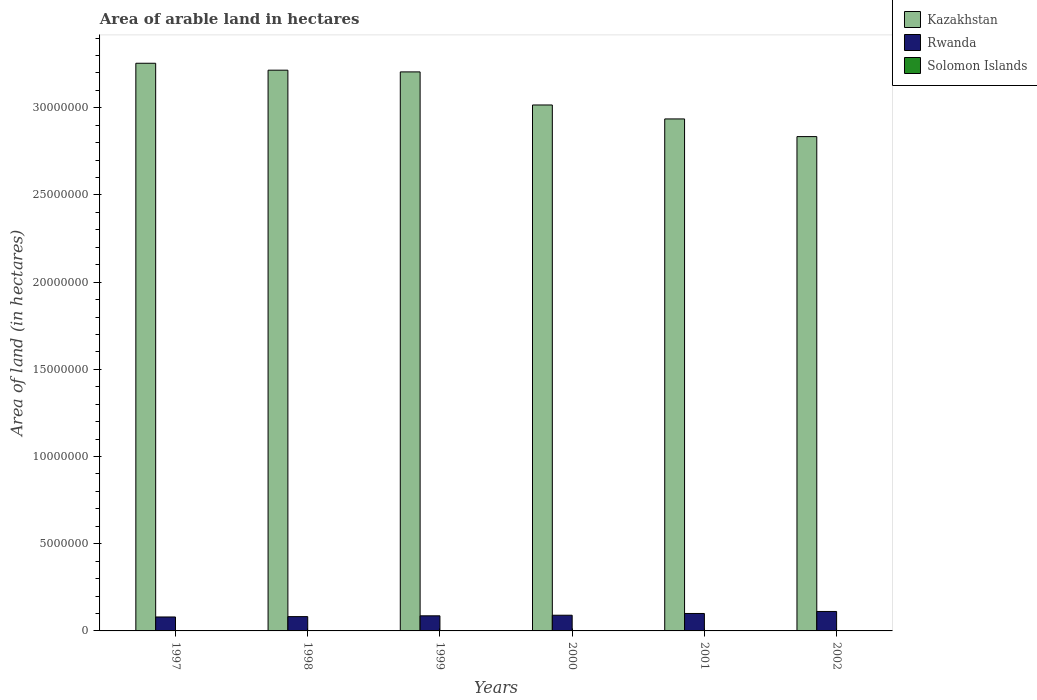How many different coloured bars are there?
Offer a very short reply. 3. How many groups of bars are there?
Keep it short and to the point. 6. Are the number of bars per tick equal to the number of legend labels?
Provide a short and direct response. Yes. Are the number of bars on each tick of the X-axis equal?
Your answer should be compact. Yes. How many bars are there on the 1st tick from the left?
Your answer should be very brief. 3. How many bars are there on the 1st tick from the right?
Your response must be concise. 3. What is the total arable land in Solomon Islands in 1999?
Your answer should be compact. 1.40e+04. Across all years, what is the maximum total arable land in Solomon Islands?
Your answer should be very brief. 1.50e+04. Across all years, what is the minimum total arable land in Solomon Islands?
Provide a succinct answer. 1.20e+04. What is the total total arable land in Solomon Islands in the graph?
Offer a very short reply. 8.30e+04. What is the difference between the total arable land in Rwanda in 1999 and that in 2002?
Offer a very short reply. -2.50e+05. What is the difference between the total arable land in Rwanda in 1998 and the total arable land in Solomon Islands in 1997?
Ensure brevity in your answer.  8.08e+05. What is the average total arable land in Kazakhstan per year?
Ensure brevity in your answer.  3.08e+07. In the year 2002, what is the difference between the total arable land in Rwanda and total arable land in Solomon Islands?
Offer a very short reply. 1.10e+06. What is the ratio of the total arable land in Rwanda in 1999 to that in 2002?
Your answer should be compact. 0.78. What is the difference between the highest and the second highest total arable land in Rwanda?
Keep it short and to the point. 1.16e+05. What is the difference between the highest and the lowest total arable land in Solomon Islands?
Make the answer very short. 3000. Is the sum of the total arable land in Solomon Islands in 1997 and 1998 greater than the maximum total arable land in Rwanda across all years?
Make the answer very short. No. What does the 2nd bar from the left in 2001 represents?
Offer a very short reply. Rwanda. What does the 2nd bar from the right in 2002 represents?
Your answer should be very brief. Rwanda. Is it the case that in every year, the sum of the total arable land in Kazakhstan and total arable land in Rwanda is greater than the total arable land in Solomon Islands?
Your answer should be very brief. Yes. How many bars are there?
Offer a terse response. 18. Are all the bars in the graph horizontal?
Your answer should be compact. No. Does the graph contain grids?
Make the answer very short. No. Where does the legend appear in the graph?
Your answer should be compact. Top right. How are the legend labels stacked?
Your response must be concise. Vertical. What is the title of the graph?
Provide a succinct answer. Area of arable land in hectares. What is the label or title of the Y-axis?
Keep it short and to the point. Area of land (in hectares). What is the Area of land (in hectares) in Kazakhstan in 1997?
Your answer should be very brief. 3.26e+07. What is the Area of land (in hectares) in Solomon Islands in 1997?
Make the answer very short. 1.20e+04. What is the Area of land (in hectares) of Kazakhstan in 1998?
Offer a very short reply. 3.22e+07. What is the Area of land (in hectares) of Rwanda in 1998?
Give a very brief answer. 8.20e+05. What is the Area of land (in hectares) in Solomon Islands in 1998?
Ensure brevity in your answer.  1.30e+04. What is the Area of land (in hectares) in Kazakhstan in 1999?
Ensure brevity in your answer.  3.21e+07. What is the Area of land (in hectares) in Rwanda in 1999?
Provide a short and direct response. 8.66e+05. What is the Area of land (in hectares) of Solomon Islands in 1999?
Keep it short and to the point. 1.40e+04. What is the Area of land (in hectares) of Kazakhstan in 2000?
Provide a succinct answer. 3.02e+07. What is the Area of land (in hectares) of Solomon Islands in 2000?
Make the answer very short. 1.40e+04. What is the Area of land (in hectares) of Kazakhstan in 2001?
Make the answer very short. 2.94e+07. What is the Area of land (in hectares) in Rwanda in 2001?
Ensure brevity in your answer.  1.00e+06. What is the Area of land (in hectares) in Solomon Islands in 2001?
Offer a terse response. 1.50e+04. What is the Area of land (in hectares) of Kazakhstan in 2002?
Provide a succinct answer. 2.83e+07. What is the Area of land (in hectares) in Rwanda in 2002?
Keep it short and to the point. 1.12e+06. What is the Area of land (in hectares) of Solomon Islands in 2002?
Make the answer very short. 1.50e+04. Across all years, what is the maximum Area of land (in hectares) in Kazakhstan?
Your answer should be very brief. 3.26e+07. Across all years, what is the maximum Area of land (in hectares) in Rwanda?
Offer a very short reply. 1.12e+06. Across all years, what is the maximum Area of land (in hectares) of Solomon Islands?
Make the answer very short. 1.50e+04. Across all years, what is the minimum Area of land (in hectares) of Kazakhstan?
Give a very brief answer. 2.83e+07. Across all years, what is the minimum Area of land (in hectares) in Rwanda?
Make the answer very short. 8.00e+05. Across all years, what is the minimum Area of land (in hectares) in Solomon Islands?
Make the answer very short. 1.20e+04. What is the total Area of land (in hectares) in Kazakhstan in the graph?
Ensure brevity in your answer.  1.85e+08. What is the total Area of land (in hectares) of Rwanda in the graph?
Offer a very short reply. 5.50e+06. What is the total Area of land (in hectares) in Solomon Islands in the graph?
Provide a short and direct response. 8.30e+04. What is the difference between the Area of land (in hectares) in Kazakhstan in 1997 and that in 1998?
Keep it short and to the point. 3.97e+05. What is the difference between the Area of land (in hectares) in Rwanda in 1997 and that in 1998?
Provide a succinct answer. -2.00e+04. What is the difference between the Area of land (in hectares) in Solomon Islands in 1997 and that in 1998?
Offer a very short reply. -1000. What is the difference between the Area of land (in hectares) in Kazakhstan in 1997 and that in 1999?
Your answer should be compact. 4.96e+05. What is the difference between the Area of land (in hectares) in Rwanda in 1997 and that in 1999?
Your answer should be very brief. -6.60e+04. What is the difference between the Area of land (in hectares) in Solomon Islands in 1997 and that in 1999?
Ensure brevity in your answer.  -2000. What is the difference between the Area of land (in hectares) of Kazakhstan in 1997 and that in 2000?
Offer a terse response. 2.39e+06. What is the difference between the Area of land (in hectares) in Rwanda in 1997 and that in 2000?
Make the answer very short. -1.00e+05. What is the difference between the Area of land (in hectares) in Solomon Islands in 1997 and that in 2000?
Make the answer very short. -2000. What is the difference between the Area of land (in hectares) in Kazakhstan in 1997 and that in 2001?
Your answer should be compact. 3.19e+06. What is the difference between the Area of land (in hectares) in Rwanda in 1997 and that in 2001?
Provide a short and direct response. -2.00e+05. What is the difference between the Area of land (in hectares) in Solomon Islands in 1997 and that in 2001?
Your answer should be very brief. -3000. What is the difference between the Area of land (in hectares) in Kazakhstan in 1997 and that in 2002?
Your answer should be compact. 4.21e+06. What is the difference between the Area of land (in hectares) of Rwanda in 1997 and that in 2002?
Offer a very short reply. -3.16e+05. What is the difference between the Area of land (in hectares) of Solomon Islands in 1997 and that in 2002?
Provide a short and direct response. -3000. What is the difference between the Area of land (in hectares) in Kazakhstan in 1998 and that in 1999?
Keep it short and to the point. 9.85e+04. What is the difference between the Area of land (in hectares) of Rwanda in 1998 and that in 1999?
Keep it short and to the point. -4.60e+04. What is the difference between the Area of land (in hectares) in Solomon Islands in 1998 and that in 1999?
Provide a succinct answer. -1000. What is the difference between the Area of land (in hectares) of Kazakhstan in 1998 and that in 2000?
Keep it short and to the point. 2.00e+06. What is the difference between the Area of land (in hectares) in Solomon Islands in 1998 and that in 2000?
Provide a short and direct response. -1000. What is the difference between the Area of land (in hectares) of Kazakhstan in 1998 and that in 2001?
Give a very brief answer. 2.80e+06. What is the difference between the Area of land (in hectares) of Rwanda in 1998 and that in 2001?
Provide a short and direct response. -1.80e+05. What is the difference between the Area of land (in hectares) of Solomon Islands in 1998 and that in 2001?
Make the answer very short. -2000. What is the difference between the Area of land (in hectares) of Kazakhstan in 1998 and that in 2002?
Make the answer very short. 3.81e+06. What is the difference between the Area of land (in hectares) in Rwanda in 1998 and that in 2002?
Offer a terse response. -2.96e+05. What is the difference between the Area of land (in hectares) in Solomon Islands in 1998 and that in 2002?
Keep it short and to the point. -2000. What is the difference between the Area of land (in hectares) of Kazakhstan in 1999 and that in 2000?
Provide a short and direct response. 1.90e+06. What is the difference between the Area of land (in hectares) in Rwanda in 1999 and that in 2000?
Provide a short and direct response. -3.40e+04. What is the difference between the Area of land (in hectares) in Solomon Islands in 1999 and that in 2000?
Your response must be concise. 0. What is the difference between the Area of land (in hectares) in Kazakhstan in 1999 and that in 2001?
Your answer should be very brief. 2.70e+06. What is the difference between the Area of land (in hectares) in Rwanda in 1999 and that in 2001?
Offer a terse response. -1.34e+05. What is the difference between the Area of land (in hectares) in Solomon Islands in 1999 and that in 2001?
Provide a short and direct response. -1000. What is the difference between the Area of land (in hectares) of Kazakhstan in 1999 and that in 2002?
Offer a very short reply. 3.71e+06. What is the difference between the Area of land (in hectares) of Rwanda in 1999 and that in 2002?
Provide a short and direct response. -2.50e+05. What is the difference between the Area of land (in hectares) of Solomon Islands in 1999 and that in 2002?
Give a very brief answer. -1000. What is the difference between the Area of land (in hectares) of Kazakhstan in 2000 and that in 2001?
Your answer should be very brief. 8.00e+05. What is the difference between the Area of land (in hectares) in Rwanda in 2000 and that in 2001?
Offer a very short reply. -1.00e+05. What is the difference between the Area of land (in hectares) of Solomon Islands in 2000 and that in 2001?
Give a very brief answer. -1000. What is the difference between the Area of land (in hectares) in Kazakhstan in 2000 and that in 2002?
Your answer should be very brief. 1.81e+06. What is the difference between the Area of land (in hectares) of Rwanda in 2000 and that in 2002?
Your answer should be compact. -2.16e+05. What is the difference between the Area of land (in hectares) of Solomon Islands in 2000 and that in 2002?
Your answer should be very brief. -1000. What is the difference between the Area of land (in hectares) of Kazakhstan in 2001 and that in 2002?
Your answer should be very brief. 1.01e+06. What is the difference between the Area of land (in hectares) in Rwanda in 2001 and that in 2002?
Give a very brief answer. -1.16e+05. What is the difference between the Area of land (in hectares) in Kazakhstan in 1997 and the Area of land (in hectares) in Rwanda in 1998?
Give a very brief answer. 3.17e+07. What is the difference between the Area of land (in hectares) of Kazakhstan in 1997 and the Area of land (in hectares) of Solomon Islands in 1998?
Offer a terse response. 3.25e+07. What is the difference between the Area of land (in hectares) in Rwanda in 1997 and the Area of land (in hectares) in Solomon Islands in 1998?
Give a very brief answer. 7.87e+05. What is the difference between the Area of land (in hectares) of Kazakhstan in 1997 and the Area of land (in hectares) of Rwanda in 1999?
Offer a very short reply. 3.17e+07. What is the difference between the Area of land (in hectares) in Kazakhstan in 1997 and the Area of land (in hectares) in Solomon Islands in 1999?
Your response must be concise. 3.25e+07. What is the difference between the Area of land (in hectares) of Rwanda in 1997 and the Area of land (in hectares) of Solomon Islands in 1999?
Your answer should be very brief. 7.86e+05. What is the difference between the Area of land (in hectares) in Kazakhstan in 1997 and the Area of land (in hectares) in Rwanda in 2000?
Provide a short and direct response. 3.17e+07. What is the difference between the Area of land (in hectares) of Kazakhstan in 1997 and the Area of land (in hectares) of Solomon Islands in 2000?
Offer a terse response. 3.25e+07. What is the difference between the Area of land (in hectares) in Rwanda in 1997 and the Area of land (in hectares) in Solomon Islands in 2000?
Your answer should be very brief. 7.86e+05. What is the difference between the Area of land (in hectares) in Kazakhstan in 1997 and the Area of land (in hectares) in Rwanda in 2001?
Ensure brevity in your answer.  3.16e+07. What is the difference between the Area of land (in hectares) in Kazakhstan in 1997 and the Area of land (in hectares) in Solomon Islands in 2001?
Make the answer very short. 3.25e+07. What is the difference between the Area of land (in hectares) in Rwanda in 1997 and the Area of land (in hectares) in Solomon Islands in 2001?
Give a very brief answer. 7.85e+05. What is the difference between the Area of land (in hectares) in Kazakhstan in 1997 and the Area of land (in hectares) in Rwanda in 2002?
Provide a short and direct response. 3.14e+07. What is the difference between the Area of land (in hectares) in Kazakhstan in 1997 and the Area of land (in hectares) in Solomon Islands in 2002?
Provide a succinct answer. 3.25e+07. What is the difference between the Area of land (in hectares) in Rwanda in 1997 and the Area of land (in hectares) in Solomon Islands in 2002?
Your response must be concise. 7.85e+05. What is the difference between the Area of land (in hectares) in Kazakhstan in 1998 and the Area of land (in hectares) in Rwanda in 1999?
Your answer should be very brief. 3.13e+07. What is the difference between the Area of land (in hectares) in Kazakhstan in 1998 and the Area of land (in hectares) in Solomon Islands in 1999?
Your response must be concise. 3.21e+07. What is the difference between the Area of land (in hectares) in Rwanda in 1998 and the Area of land (in hectares) in Solomon Islands in 1999?
Keep it short and to the point. 8.06e+05. What is the difference between the Area of land (in hectares) in Kazakhstan in 1998 and the Area of land (in hectares) in Rwanda in 2000?
Provide a short and direct response. 3.13e+07. What is the difference between the Area of land (in hectares) in Kazakhstan in 1998 and the Area of land (in hectares) in Solomon Islands in 2000?
Your answer should be very brief. 3.21e+07. What is the difference between the Area of land (in hectares) of Rwanda in 1998 and the Area of land (in hectares) of Solomon Islands in 2000?
Your answer should be compact. 8.06e+05. What is the difference between the Area of land (in hectares) of Kazakhstan in 1998 and the Area of land (in hectares) of Rwanda in 2001?
Provide a short and direct response. 3.12e+07. What is the difference between the Area of land (in hectares) of Kazakhstan in 1998 and the Area of land (in hectares) of Solomon Islands in 2001?
Provide a short and direct response. 3.21e+07. What is the difference between the Area of land (in hectares) of Rwanda in 1998 and the Area of land (in hectares) of Solomon Islands in 2001?
Your response must be concise. 8.05e+05. What is the difference between the Area of land (in hectares) of Kazakhstan in 1998 and the Area of land (in hectares) of Rwanda in 2002?
Your response must be concise. 3.10e+07. What is the difference between the Area of land (in hectares) of Kazakhstan in 1998 and the Area of land (in hectares) of Solomon Islands in 2002?
Offer a terse response. 3.21e+07. What is the difference between the Area of land (in hectares) of Rwanda in 1998 and the Area of land (in hectares) of Solomon Islands in 2002?
Give a very brief answer. 8.05e+05. What is the difference between the Area of land (in hectares) in Kazakhstan in 1999 and the Area of land (in hectares) in Rwanda in 2000?
Offer a very short reply. 3.12e+07. What is the difference between the Area of land (in hectares) of Kazakhstan in 1999 and the Area of land (in hectares) of Solomon Islands in 2000?
Your answer should be very brief. 3.20e+07. What is the difference between the Area of land (in hectares) of Rwanda in 1999 and the Area of land (in hectares) of Solomon Islands in 2000?
Your response must be concise. 8.52e+05. What is the difference between the Area of land (in hectares) of Kazakhstan in 1999 and the Area of land (in hectares) of Rwanda in 2001?
Keep it short and to the point. 3.11e+07. What is the difference between the Area of land (in hectares) of Kazakhstan in 1999 and the Area of land (in hectares) of Solomon Islands in 2001?
Offer a very short reply. 3.20e+07. What is the difference between the Area of land (in hectares) in Rwanda in 1999 and the Area of land (in hectares) in Solomon Islands in 2001?
Your answer should be very brief. 8.51e+05. What is the difference between the Area of land (in hectares) of Kazakhstan in 1999 and the Area of land (in hectares) of Rwanda in 2002?
Provide a succinct answer. 3.09e+07. What is the difference between the Area of land (in hectares) of Kazakhstan in 1999 and the Area of land (in hectares) of Solomon Islands in 2002?
Ensure brevity in your answer.  3.20e+07. What is the difference between the Area of land (in hectares) in Rwanda in 1999 and the Area of land (in hectares) in Solomon Islands in 2002?
Make the answer very short. 8.51e+05. What is the difference between the Area of land (in hectares) in Kazakhstan in 2000 and the Area of land (in hectares) in Rwanda in 2001?
Keep it short and to the point. 2.92e+07. What is the difference between the Area of land (in hectares) of Kazakhstan in 2000 and the Area of land (in hectares) of Solomon Islands in 2001?
Keep it short and to the point. 3.01e+07. What is the difference between the Area of land (in hectares) of Rwanda in 2000 and the Area of land (in hectares) of Solomon Islands in 2001?
Keep it short and to the point. 8.85e+05. What is the difference between the Area of land (in hectares) of Kazakhstan in 2000 and the Area of land (in hectares) of Rwanda in 2002?
Keep it short and to the point. 2.90e+07. What is the difference between the Area of land (in hectares) in Kazakhstan in 2000 and the Area of land (in hectares) in Solomon Islands in 2002?
Offer a terse response. 3.01e+07. What is the difference between the Area of land (in hectares) of Rwanda in 2000 and the Area of land (in hectares) of Solomon Islands in 2002?
Ensure brevity in your answer.  8.85e+05. What is the difference between the Area of land (in hectares) in Kazakhstan in 2001 and the Area of land (in hectares) in Rwanda in 2002?
Ensure brevity in your answer.  2.82e+07. What is the difference between the Area of land (in hectares) of Kazakhstan in 2001 and the Area of land (in hectares) of Solomon Islands in 2002?
Keep it short and to the point. 2.93e+07. What is the difference between the Area of land (in hectares) in Rwanda in 2001 and the Area of land (in hectares) in Solomon Islands in 2002?
Offer a terse response. 9.85e+05. What is the average Area of land (in hectares) of Kazakhstan per year?
Your answer should be compact. 3.08e+07. What is the average Area of land (in hectares) in Rwanda per year?
Give a very brief answer. 9.17e+05. What is the average Area of land (in hectares) in Solomon Islands per year?
Ensure brevity in your answer.  1.38e+04. In the year 1997, what is the difference between the Area of land (in hectares) of Kazakhstan and Area of land (in hectares) of Rwanda?
Provide a succinct answer. 3.18e+07. In the year 1997, what is the difference between the Area of land (in hectares) of Kazakhstan and Area of land (in hectares) of Solomon Islands?
Provide a succinct answer. 3.25e+07. In the year 1997, what is the difference between the Area of land (in hectares) of Rwanda and Area of land (in hectares) of Solomon Islands?
Offer a very short reply. 7.88e+05. In the year 1998, what is the difference between the Area of land (in hectares) of Kazakhstan and Area of land (in hectares) of Rwanda?
Offer a terse response. 3.13e+07. In the year 1998, what is the difference between the Area of land (in hectares) of Kazakhstan and Area of land (in hectares) of Solomon Islands?
Keep it short and to the point. 3.21e+07. In the year 1998, what is the difference between the Area of land (in hectares) of Rwanda and Area of land (in hectares) of Solomon Islands?
Your answer should be very brief. 8.07e+05. In the year 1999, what is the difference between the Area of land (in hectares) of Kazakhstan and Area of land (in hectares) of Rwanda?
Keep it short and to the point. 3.12e+07. In the year 1999, what is the difference between the Area of land (in hectares) of Kazakhstan and Area of land (in hectares) of Solomon Islands?
Your response must be concise. 3.20e+07. In the year 1999, what is the difference between the Area of land (in hectares) in Rwanda and Area of land (in hectares) in Solomon Islands?
Offer a very short reply. 8.52e+05. In the year 2000, what is the difference between the Area of land (in hectares) of Kazakhstan and Area of land (in hectares) of Rwanda?
Your response must be concise. 2.93e+07. In the year 2000, what is the difference between the Area of land (in hectares) of Kazakhstan and Area of land (in hectares) of Solomon Islands?
Your answer should be very brief. 3.01e+07. In the year 2000, what is the difference between the Area of land (in hectares) of Rwanda and Area of land (in hectares) of Solomon Islands?
Provide a short and direct response. 8.86e+05. In the year 2001, what is the difference between the Area of land (in hectares) in Kazakhstan and Area of land (in hectares) in Rwanda?
Offer a very short reply. 2.84e+07. In the year 2001, what is the difference between the Area of land (in hectares) of Kazakhstan and Area of land (in hectares) of Solomon Islands?
Your answer should be compact. 2.93e+07. In the year 2001, what is the difference between the Area of land (in hectares) of Rwanda and Area of land (in hectares) of Solomon Islands?
Offer a very short reply. 9.85e+05. In the year 2002, what is the difference between the Area of land (in hectares) of Kazakhstan and Area of land (in hectares) of Rwanda?
Your answer should be very brief. 2.72e+07. In the year 2002, what is the difference between the Area of land (in hectares) of Kazakhstan and Area of land (in hectares) of Solomon Islands?
Your response must be concise. 2.83e+07. In the year 2002, what is the difference between the Area of land (in hectares) in Rwanda and Area of land (in hectares) in Solomon Islands?
Give a very brief answer. 1.10e+06. What is the ratio of the Area of land (in hectares) of Kazakhstan in 1997 to that in 1998?
Your response must be concise. 1.01. What is the ratio of the Area of land (in hectares) of Rwanda in 1997 to that in 1998?
Provide a succinct answer. 0.98. What is the ratio of the Area of land (in hectares) in Kazakhstan in 1997 to that in 1999?
Offer a terse response. 1.02. What is the ratio of the Area of land (in hectares) of Rwanda in 1997 to that in 1999?
Keep it short and to the point. 0.92. What is the ratio of the Area of land (in hectares) of Kazakhstan in 1997 to that in 2000?
Your answer should be very brief. 1.08. What is the ratio of the Area of land (in hectares) of Rwanda in 1997 to that in 2000?
Give a very brief answer. 0.89. What is the ratio of the Area of land (in hectares) of Solomon Islands in 1997 to that in 2000?
Provide a succinct answer. 0.86. What is the ratio of the Area of land (in hectares) of Kazakhstan in 1997 to that in 2001?
Provide a short and direct response. 1.11. What is the ratio of the Area of land (in hectares) of Kazakhstan in 1997 to that in 2002?
Provide a short and direct response. 1.15. What is the ratio of the Area of land (in hectares) of Rwanda in 1997 to that in 2002?
Your answer should be compact. 0.72. What is the ratio of the Area of land (in hectares) in Rwanda in 1998 to that in 1999?
Ensure brevity in your answer.  0.95. What is the ratio of the Area of land (in hectares) of Kazakhstan in 1998 to that in 2000?
Keep it short and to the point. 1.07. What is the ratio of the Area of land (in hectares) in Rwanda in 1998 to that in 2000?
Ensure brevity in your answer.  0.91. What is the ratio of the Area of land (in hectares) in Solomon Islands in 1998 to that in 2000?
Provide a succinct answer. 0.93. What is the ratio of the Area of land (in hectares) in Kazakhstan in 1998 to that in 2001?
Offer a terse response. 1.1. What is the ratio of the Area of land (in hectares) of Rwanda in 1998 to that in 2001?
Provide a succinct answer. 0.82. What is the ratio of the Area of land (in hectares) in Solomon Islands in 1998 to that in 2001?
Your answer should be very brief. 0.87. What is the ratio of the Area of land (in hectares) of Kazakhstan in 1998 to that in 2002?
Your answer should be very brief. 1.13. What is the ratio of the Area of land (in hectares) of Rwanda in 1998 to that in 2002?
Provide a short and direct response. 0.73. What is the ratio of the Area of land (in hectares) in Solomon Islands in 1998 to that in 2002?
Ensure brevity in your answer.  0.87. What is the ratio of the Area of land (in hectares) in Kazakhstan in 1999 to that in 2000?
Provide a succinct answer. 1.06. What is the ratio of the Area of land (in hectares) of Rwanda in 1999 to that in 2000?
Provide a succinct answer. 0.96. What is the ratio of the Area of land (in hectares) of Kazakhstan in 1999 to that in 2001?
Your answer should be very brief. 1.09. What is the ratio of the Area of land (in hectares) in Rwanda in 1999 to that in 2001?
Provide a succinct answer. 0.87. What is the ratio of the Area of land (in hectares) in Solomon Islands in 1999 to that in 2001?
Your answer should be very brief. 0.93. What is the ratio of the Area of land (in hectares) in Kazakhstan in 1999 to that in 2002?
Your response must be concise. 1.13. What is the ratio of the Area of land (in hectares) in Rwanda in 1999 to that in 2002?
Your response must be concise. 0.78. What is the ratio of the Area of land (in hectares) in Kazakhstan in 2000 to that in 2001?
Your answer should be compact. 1.03. What is the ratio of the Area of land (in hectares) in Kazakhstan in 2000 to that in 2002?
Your answer should be very brief. 1.06. What is the ratio of the Area of land (in hectares) of Rwanda in 2000 to that in 2002?
Make the answer very short. 0.81. What is the ratio of the Area of land (in hectares) in Kazakhstan in 2001 to that in 2002?
Keep it short and to the point. 1.04. What is the ratio of the Area of land (in hectares) of Rwanda in 2001 to that in 2002?
Your response must be concise. 0.9. What is the ratio of the Area of land (in hectares) in Solomon Islands in 2001 to that in 2002?
Your answer should be compact. 1. What is the difference between the highest and the second highest Area of land (in hectares) in Kazakhstan?
Your answer should be compact. 3.97e+05. What is the difference between the highest and the second highest Area of land (in hectares) of Rwanda?
Provide a succinct answer. 1.16e+05. What is the difference between the highest and the lowest Area of land (in hectares) in Kazakhstan?
Ensure brevity in your answer.  4.21e+06. What is the difference between the highest and the lowest Area of land (in hectares) in Rwanda?
Ensure brevity in your answer.  3.16e+05. What is the difference between the highest and the lowest Area of land (in hectares) of Solomon Islands?
Give a very brief answer. 3000. 